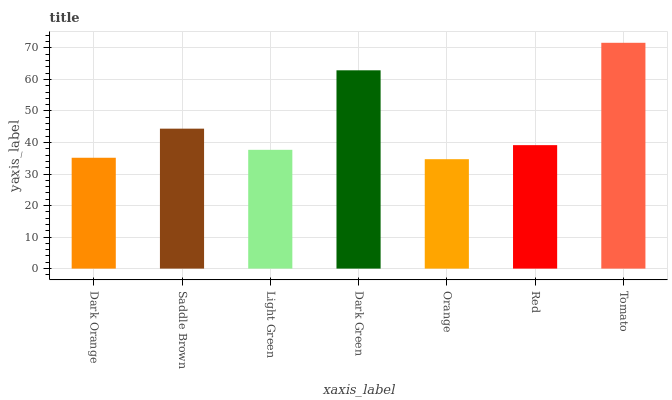Is Orange the minimum?
Answer yes or no. Yes. Is Tomato the maximum?
Answer yes or no. Yes. Is Saddle Brown the minimum?
Answer yes or no. No. Is Saddle Brown the maximum?
Answer yes or no. No. Is Saddle Brown greater than Dark Orange?
Answer yes or no. Yes. Is Dark Orange less than Saddle Brown?
Answer yes or no. Yes. Is Dark Orange greater than Saddle Brown?
Answer yes or no. No. Is Saddle Brown less than Dark Orange?
Answer yes or no. No. Is Red the high median?
Answer yes or no. Yes. Is Red the low median?
Answer yes or no. Yes. Is Saddle Brown the high median?
Answer yes or no. No. Is Saddle Brown the low median?
Answer yes or no. No. 